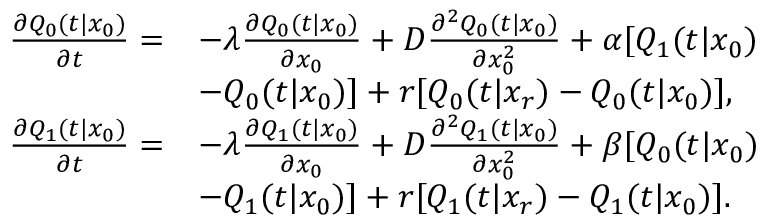<formula> <loc_0><loc_0><loc_500><loc_500>\begin{array} { r l } { \frac { \partial Q _ { 0 } ( t | x _ { 0 } ) } { \partial t } = } & { - \lambda \frac { \partial Q _ { 0 } ( t | x _ { 0 } ) } { \partial x _ { 0 } } + D \frac { \partial ^ { 2 } Q _ { 0 } ( t | x _ { 0 } ) } { \partial x _ { 0 } ^ { 2 } } + \alpha [ Q _ { 1 } ( t | x _ { 0 } ) } \\ & { - Q _ { 0 } ( t | x _ { 0 } ) ] + r [ Q _ { 0 } ( t | x _ { r } ) - Q _ { 0 } ( t | x _ { 0 } ) ] , } \\ { \frac { \partial Q _ { 1 } ( t | x _ { 0 } ) } { \partial t } = } & { - \lambda \frac { \partial Q _ { 1 } ( t | x _ { 0 } ) } { \partial x _ { 0 } } + D \frac { \partial ^ { 2 } Q _ { 1 } ( t | x _ { 0 } ) } { \partial x _ { 0 } ^ { 2 } } + \beta [ Q _ { 0 } ( t | x _ { 0 } ) } \\ & { - Q _ { 1 } ( t | x _ { 0 } ) ] + r [ Q _ { 1 } ( t | x _ { r } ) - Q _ { 1 } ( t | x _ { 0 } ) ] . } \end{array}</formula> 